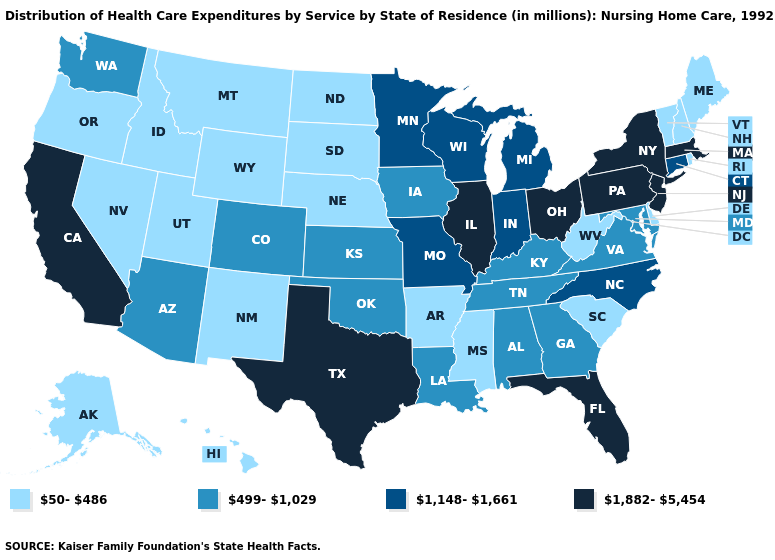Does Oregon have the lowest value in the West?
Answer briefly. Yes. Among the states that border Vermont , which have the highest value?
Give a very brief answer. Massachusetts, New York. What is the value of Texas?
Write a very short answer. 1,882-5,454. Does Kansas have the lowest value in the MidWest?
Write a very short answer. No. Which states have the lowest value in the Northeast?
Keep it brief. Maine, New Hampshire, Rhode Island, Vermont. Which states have the lowest value in the USA?
Be succinct. Alaska, Arkansas, Delaware, Hawaii, Idaho, Maine, Mississippi, Montana, Nebraska, Nevada, New Hampshire, New Mexico, North Dakota, Oregon, Rhode Island, South Carolina, South Dakota, Utah, Vermont, West Virginia, Wyoming. What is the highest value in states that border Nebraska?
Quick response, please. 1,148-1,661. Name the states that have a value in the range 1,882-5,454?
Write a very short answer. California, Florida, Illinois, Massachusetts, New Jersey, New York, Ohio, Pennsylvania, Texas. Does the map have missing data?
Short answer required. No. What is the value of Washington?
Answer briefly. 499-1,029. What is the value of Minnesota?
Give a very brief answer. 1,148-1,661. Among the states that border West Virginia , which have the lowest value?
Be succinct. Kentucky, Maryland, Virginia. Is the legend a continuous bar?
Answer briefly. No. Which states have the highest value in the USA?
Keep it brief. California, Florida, Illinois, Massachusetts, New Jersey, New York, Ohio, Pennsylvania, Texas. Which states hav the highest value in the South?
Short answer required. Florida, Texas. 